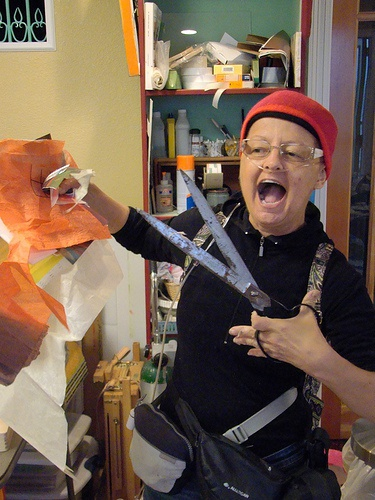Describe the objects in this image and their specific colors. I can see people in black and gray tones, backpack in black and gray tones, handbag in black, gray, and maroon tones, handbag in black and gray tones, and scissors in black and gray tones in this image. 